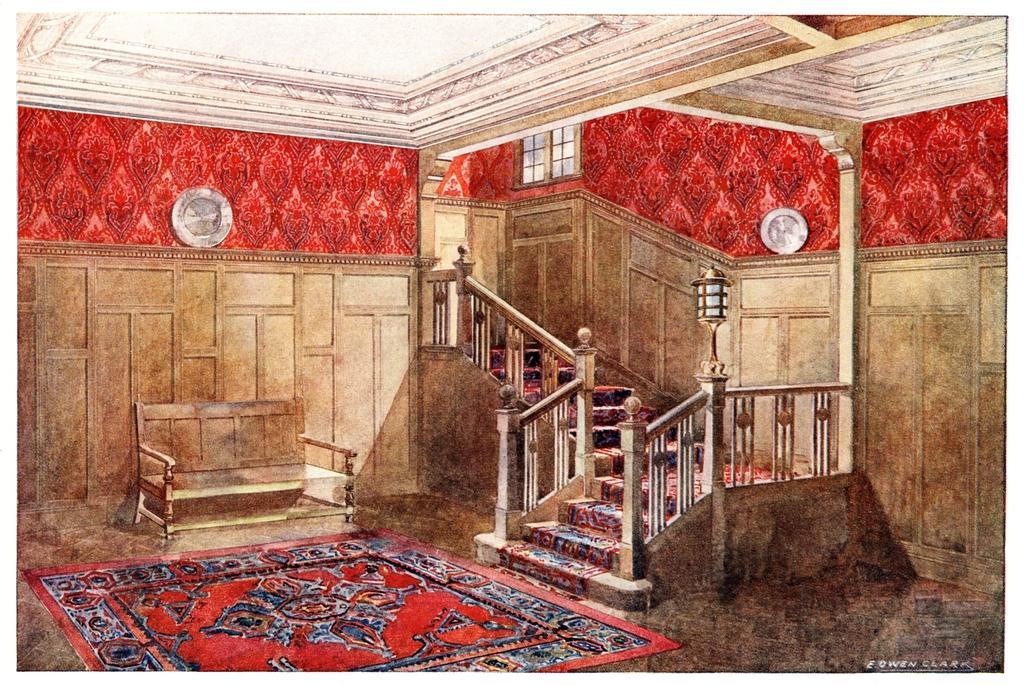How would you summarize this image in a sentence or two? In the picture I can see the red color carpet on the floor, I can see wooden bench, staircase, lamps, the wooden wall and ventilators in the background. 